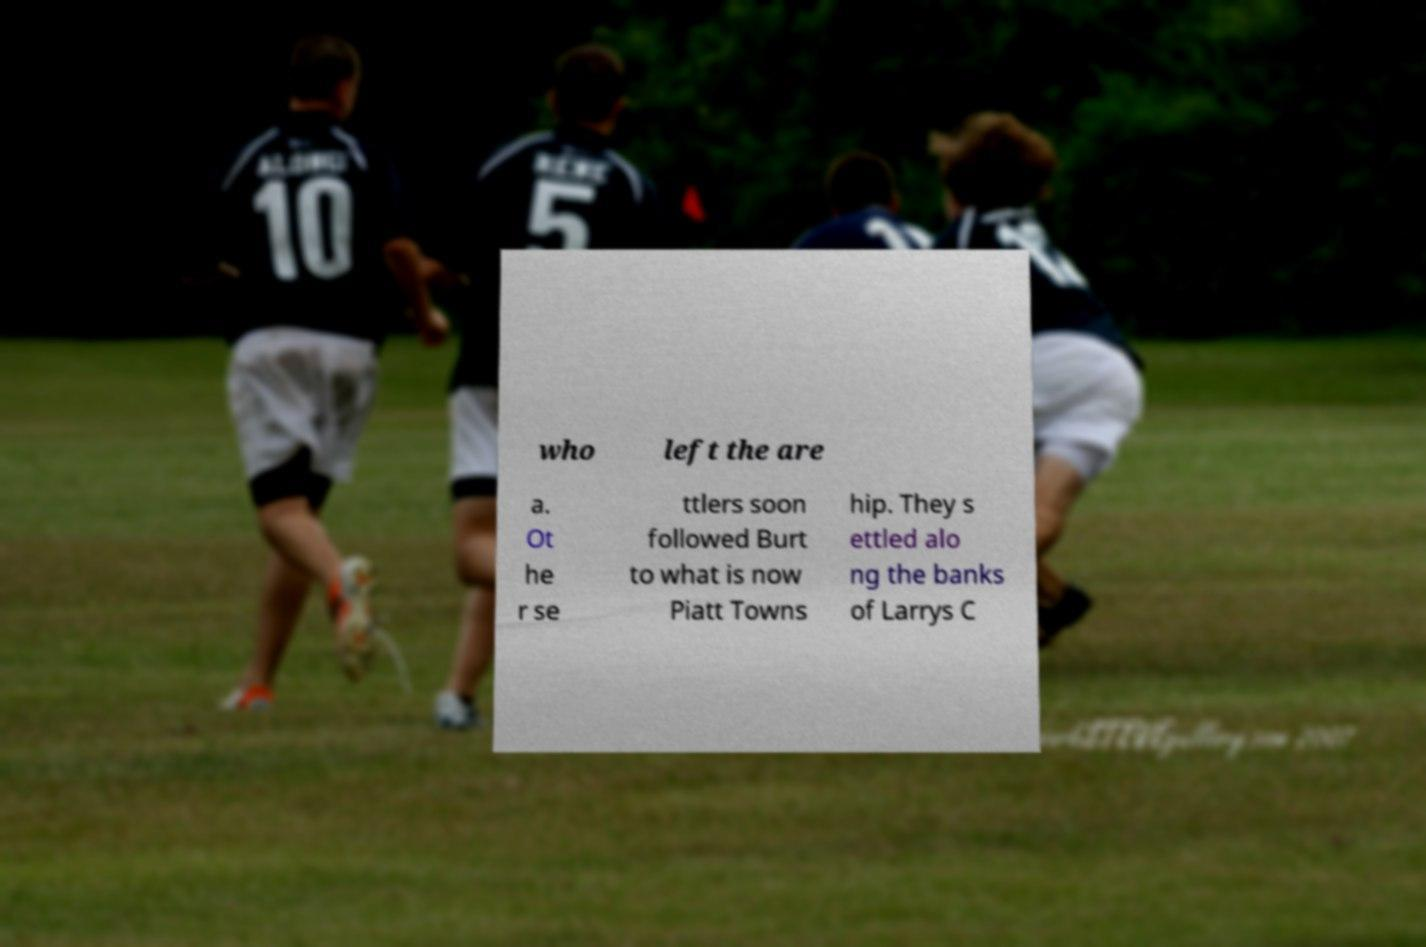Please read and relay the text visible in this image. What does it say? who left the are a. Ot he r se ttlers soon followed Burt to what is now Piatt Towns hip. They s ettled alo ng the banks of Larrys C 